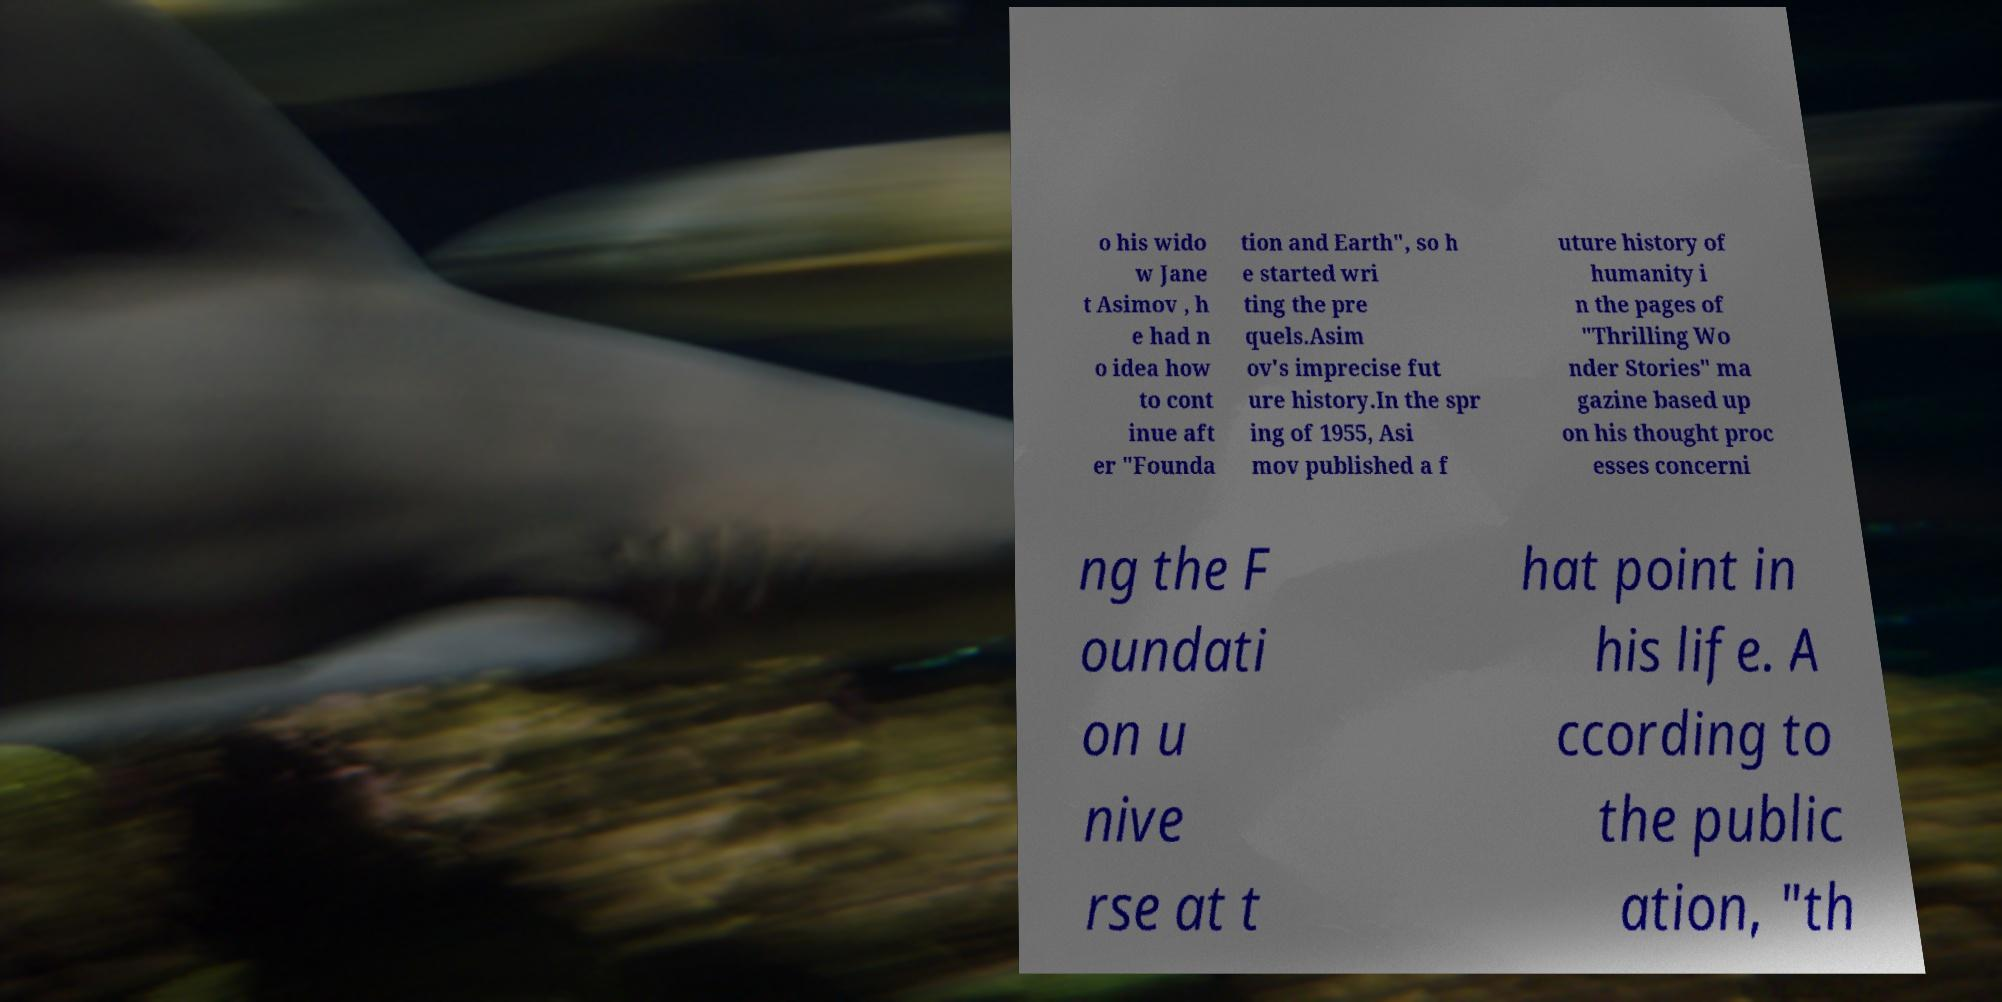Could you extract and type out the text from this image? o his wido w Jane t Asimov , h e had n o idea how to cont inue aft er "Founda tion and Earth", so h e started wri ting the pre quels.Asim ov's imprecise fut ure history.In the spr ing of 1955, Asi mov published a f uture history of humanity i n the pages of "Thrilling Wo nder Stories" ma gazine based up on his thought proc esses concerni ng the F oundati on u nive rse at t hat point in his life. A ccording to the public ation, "th 